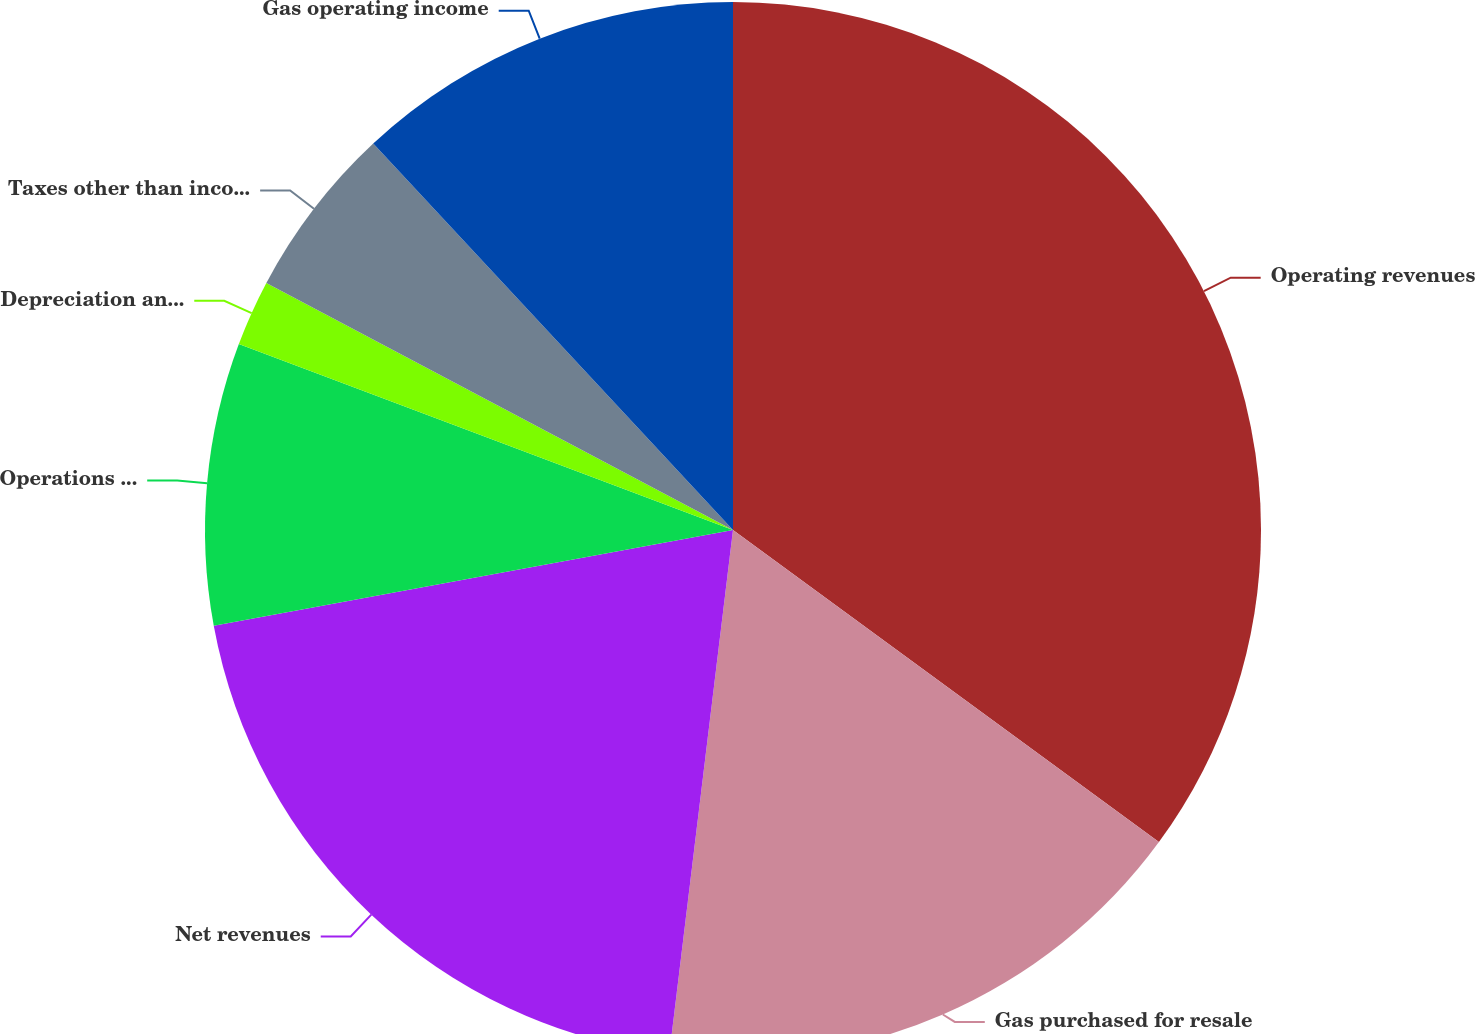Convert chart. <chart><loc_0><loc_0><loc_500><loc_500><pie_chart><fcel>Operating revenues<fcel>Gas purchased for resale<fcel>Net revenues<fcel>Operations and maintenance<fcel>Depreciation and amortization<fcel>Taxes other than income taxes<fcel>Gas operating income<nl><fcel>35.06%<fcel>16.86%<fcel>20.17%<fcel>8.63%<fcel>2.02%<fcel>5.32%<fcel>11.93%<nl></chart> 